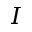<formula> <loc_0><loc_0><loc_500><loc_500>I</formula> 